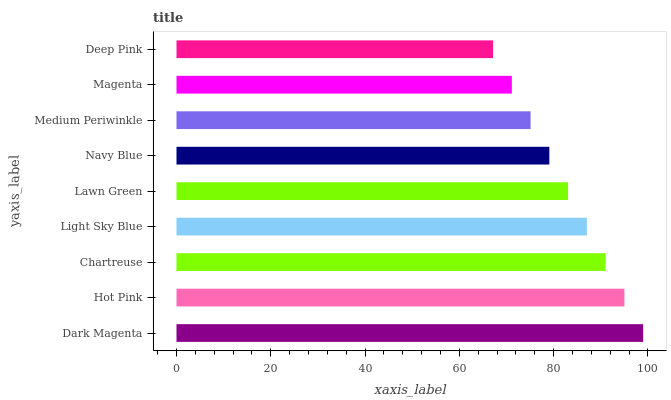Is Deep Pink the minimum?
Answer yes or no. Yes. Is Dark Magenta the maximum?
Answer yes or no. Yes. Is Hot Pink the minimum?
Answer yes or no. No. Is Hot Pink the maximum?
Answer yes or no. No. Is Dark Magenta greater than Hot Pink?
Answer yes or no. Yes. Is Hot Pink less than Dark Magenta?
Answer yes or no. Yes. Is Hot Pink greater than Dark Magenta?
Answer yes or no. No. Is Dark Magenta less than Hot Pink?
Answer yes or no. No. Is Lawn Green the high median?
Answer yes or no. Yes. Is Lawn Green the low median?
Answer yes or no. Yes. Is Medium Periwinkle the high median?
Answer yes or no. No. Is Medium Periwinkle the low median?
Answer yes or no. No. 